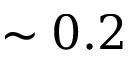Convert formula to latex. <formula><loc_0><loc_0><loc_500><loc_500>\sim 0 . 2</formula> 